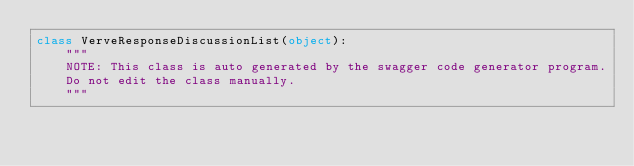<code> <loc_0><loc_0><loc_500><loc_500><_Python_>class VerveResponseDiscussionList(object):
    """
    NOTE: This class is auto generated by the swagger code generator program.
    Do not edit the class manually.
    """</code> 